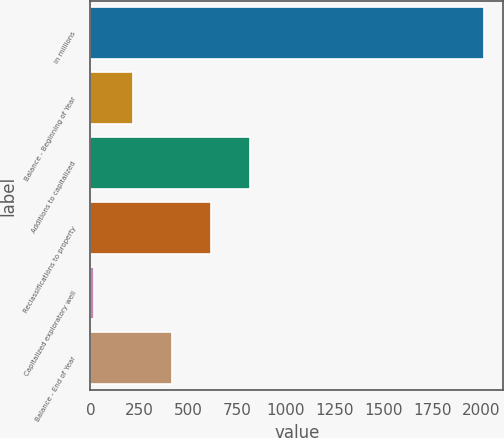<chart> <loc_0><loc_0><loc_500><loc_500><bar_chart><fcel>in millions<fcel>Balance - Beginning of Year<fcel>Additions to capitalized<fcel>Reclassifications to property<fcel>Capitalized exploratory well<fcel>Balance - End of Year<nl><fcel>2014<fcel>220.3<fcel>818.2<fcel>618.9<fcel>21<fcel>419.6<nl></chart> 